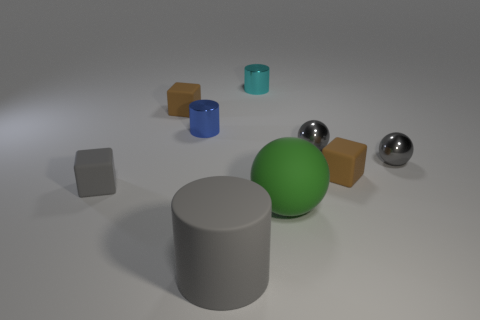Add 1 big brown metallic blocks. How many objects exist? 10 Subtract all cylinders. How many objects are left? 6 Add 1 big green balls. How many big green balls are left? 2 Add 9 matte cylinders. How many matte cylinders exist? 10 Subtract 0 brown spheres. How many objects are left? 9 Subtract all tiny blue metallic cylinders. Subtract all gray shiny objects. How many objects are left? 6 